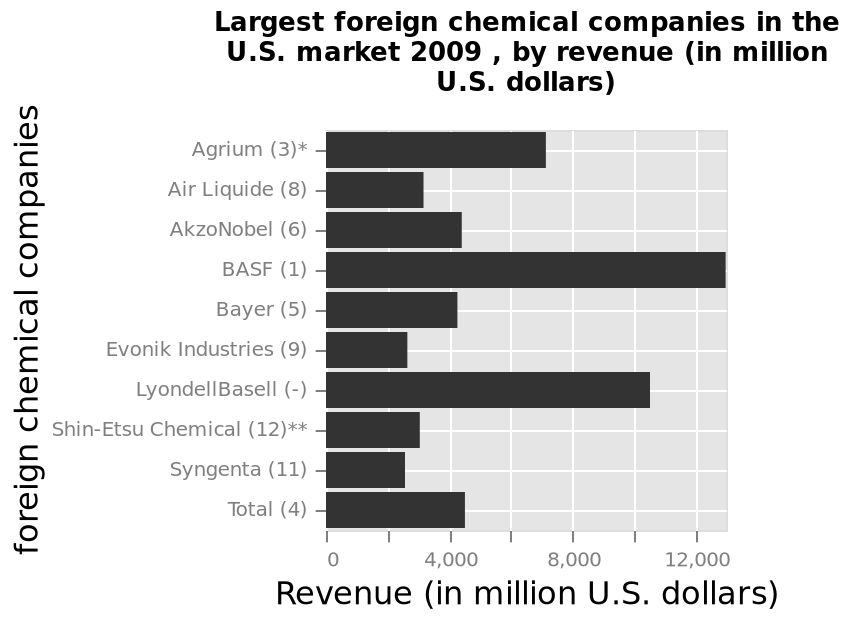<image>
What is the sales difference between Basf 1 and Evonik Industries?  Basf 1 has a sales difference of 2 million lower than Evonik Industries. 